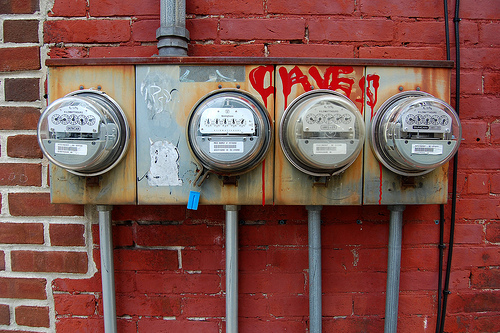<image>
Can you confirm if the pipe is above the clear covering? Yes. The pipe is positioned above the clear covering in the vertical space, higher up in the scene. 